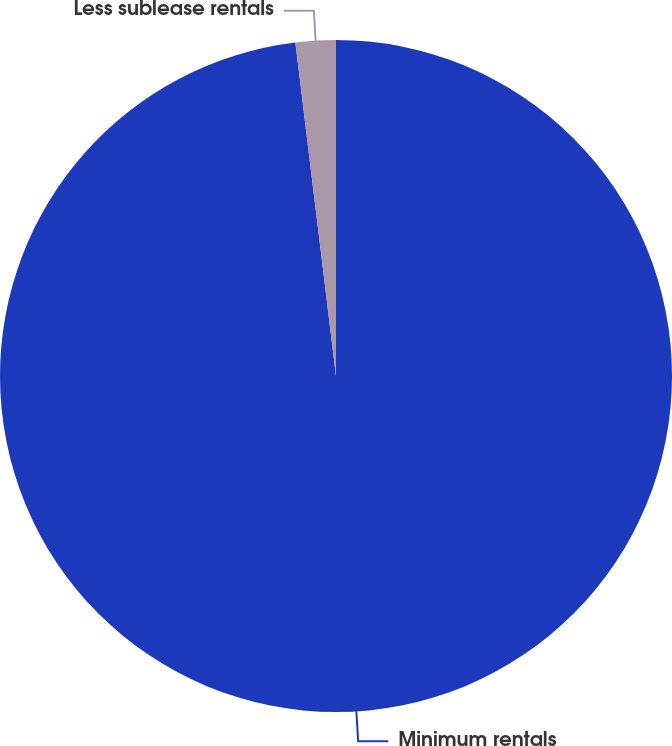Convert chart. <chart><loc_0><loc_0><loc_500><loc_500><pie_chart><fcel>Minimum rentals<fcel>Less sublease rentals<nl><fcel>98.07%<fcel>1.93%<nl></chart> 